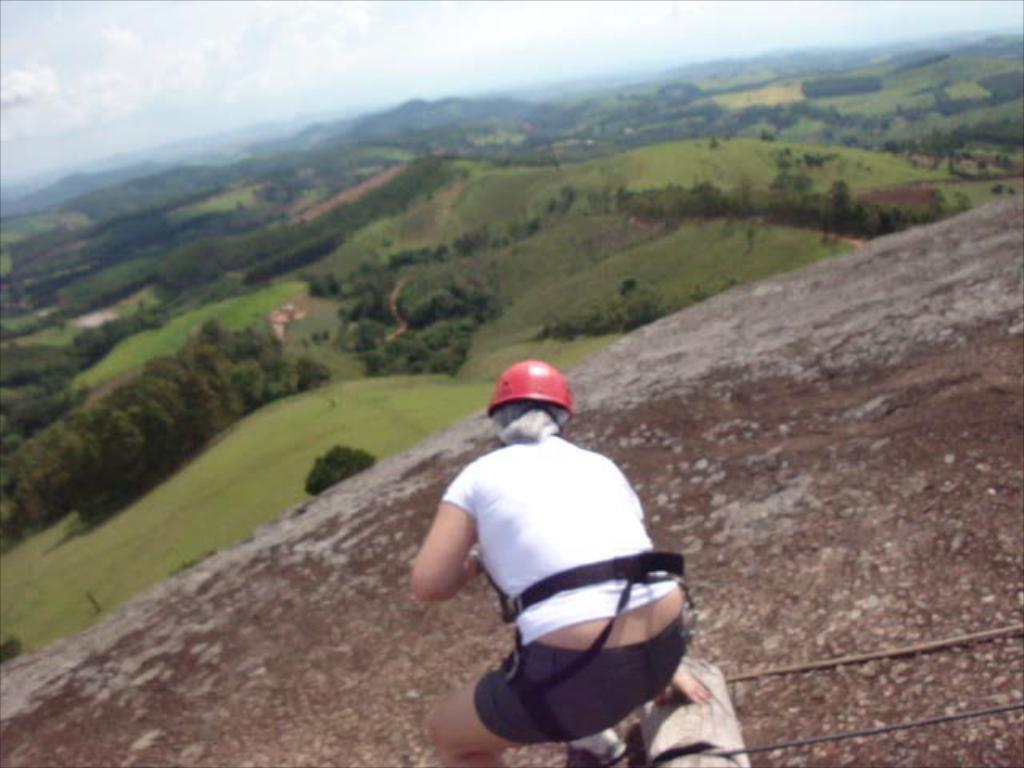What is the person in the image wearing on their head? The person in the image is wearing a helmet. Where is the person located in the image? The person is on a rock in the image. What can be seen in the background of the image? There are hills, trees, and the sky visible in the background of the image. Are there any clouds in the sky? Yes, clouds are present in the sky. What type of train can be seen passing by in the image? There is no train present in the image; it features a person on a rock with hills, trees, and clouds in the background. 